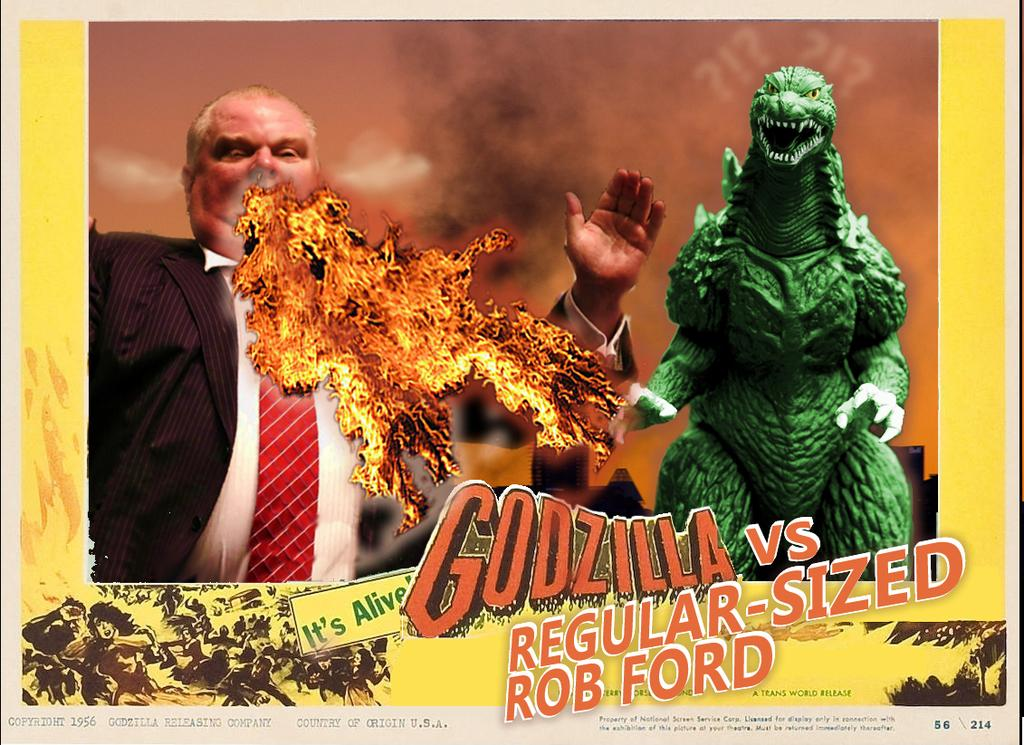What is present on the poster in the image? There is a poster in the image that contains a person, an animal, some objects, and text. Can you describe the person on the poster? Unfortunately, the specific details of the person on the poster cannot be determined from the provided facts. What type of animal is depicted on the poster? The animal on the poster cannot be identified from the provided facts. What objects are present on the poster? The specific objects on the poster cannot be determined from the provided facts. How many cattle are visible on the poster? There is no mention of cattle in the provided facts, and therefore no such animals can be observed on the poster. 